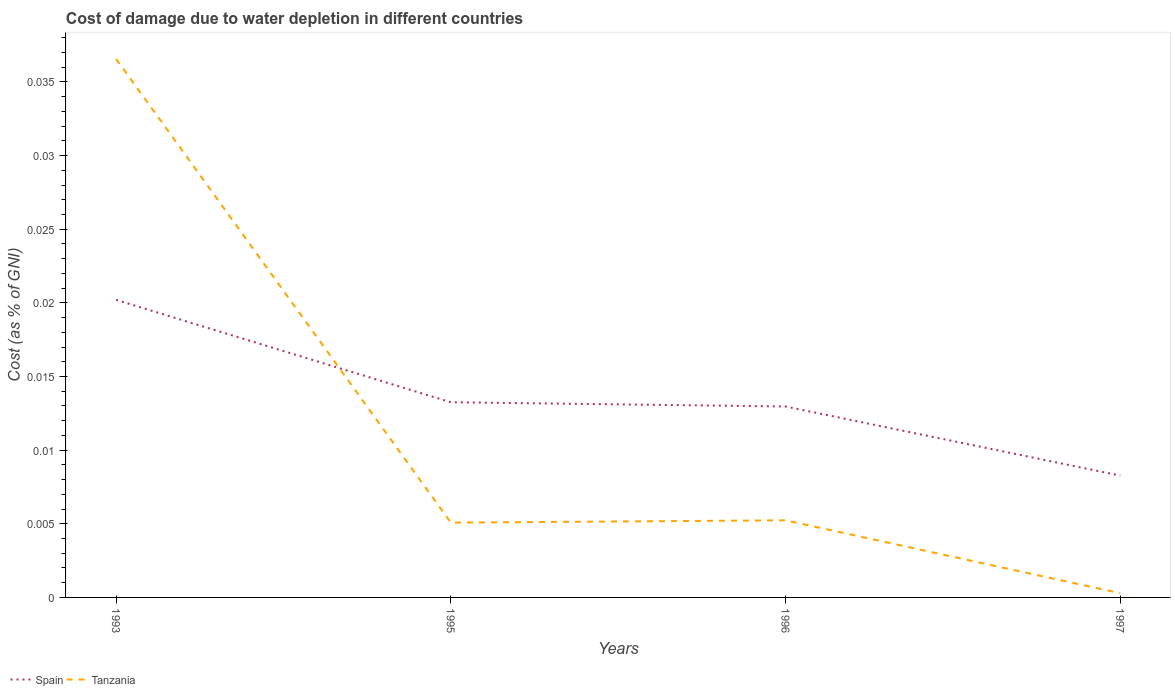Does the line corresponding to Tanzania intersect with the line corresponding to Spain?
Your answer should be very brief. Yes. Is the number of lines equal to the number of legend labels?
Provide a short and direct response. Yes. Across all years, what is the maximum cost of damage caused due to water depletion in Spain?
Your answer should be compact. 0.01. What is the total cost of damage caused due to water depletion in Spain in the graph?
Your response must be concise. 0. What is the difference between the highest and the second highest cost of damage caused due to water depletion in Tanzania?
Provide a short and direct response. 0.04. How many years are there in the graph?
Offer a terse response. 4. What is the difference between two consecutive major ticks on the Y-axis?
Your answer should be compact. 0.01. Does the graph contain any zero values?
Make the answer very short. No. Where does the legend appear in the graph?
Make the answer very short. Bottom left. How many legend labels are there?
Keep it short and to the point. 2. How are the legend labels stacked?
Your answer should be compact. Horizontal. What is the title of the graph?
Your answer should be very brief. Cost of damage due to water depletion in different countries. Does "Maldives" appear as one of the legend labels in the graph?
Your answer should be compact. No. What is the label or title of the X-axis?
Make the answer very short. Years. What is the label or title of the Y-axis?
Make the answer very short. Cost (as % of GNI). What is the Cost (as % of GNI) in Spain in 1993?
Keep it short and to the point. 0.02. What is the Cost (as % of GNI) of Tanzania in 1993?
Offer a very short reply. 0.04. What is the Cost (as % of GNI) in Spain in 1995?
Give a very brief answer. 0.01. What is the Cost (as % of GNI) of Tanzania in 1995?
Offer a very short reply. 0.01. What is the Cost (as % of GNI) in Spain in 1996?
Provide a succinct answer. 0.01. What is the Cost (as % of GNI) of Tanzania in 1996?
Provide a short and direct response. 0.01. What is the Cost (as % of GNI) in Spain in 1997?
Offer a very short reply. 0.01. What is the Cost (as % of GNI) in Tanzania in 1997?
Give a very brief answer. 0. Across all years, what is the maximum Cost (as % of GNI) of Spain?
Provide a short and direct response. 0.02. Across all years, what is the maximum Cost (as % of GNI) of Tanzania?
Your answer should be compact. 0.04. Across all years, what is the minimum Cost (as % of GNI) of Spain?
Your response must be concise. 0.01. Across all years, what is the minimum Cost (as % of GNI) of Tanzania?
Provide a short and direct response. 0. What is the total Cost (as % of GNI) of Spain in the graph?
Keep it short and to the point. 0.05. What is the total Cost (as % of GNI) in Tanzania in the graph?
Your answer should be compact. 0.05. What is the difference between the Cost (as % of GNI) of Spain in 1993 and that in 1995?
Ensure brevity in your answer.  0.01. What is the difference between the Cost (as % of GNI) of Tanzania in 1993 and that in 1995?
Offer a very short reply. 0.03. What is the difference between the Cost (as % of GNI) of Spain in 1993 and that in 1996?
Your answer should be compact. 0.01. What is the difference between the Cost (as % of GNI) in Tanzania in 1993 and that in 1996?
Provide a succinct answer. 0.03. What is the difference between the Cost (as % of GNI) of Spain in 1993 and that in 1997?
Your answer should be very brief. 0.01. What is the difference between the Cost (as % of GNI) of Tanzania in 1993 and that in 1997?
Your answer should be very brief. 0.04. What is the difference between the Cost (as % of GNI) in Spain in 1995 and that in 1996?
Make the answer very short. 0. What is the difference between the Cost (as % of GNI) in Tanzania in 1995 and that in 1996?
Give a very brief answer. -0. What is the difference between the Cost (as % of GNI) of Spain in 1995 and that in 1997?
Ensure brevity in your answer.  0.01. What is the difference between the Cost (as % of GNI) of Tanzania in 1995 and that in 1997?
Provide a succinct answer. 0. What is the difference between the Cost (as % of GNI) of Spain in 1996 and that in 1997?
Ensure brevity in your answer.  0. What is the difference between the Cost (as % of GNI) in Tanzania in 1996 and that in 1997?
Give a very brief answer. 0. What is the difference between the Cost (as % of GNI) of Spain in 1993 and the Cost (as % of GNI) of Tanzania in 1995?
Ensure brevity in your answer.  0.02. What is the difference between the Cost (as % of GNI) of Spain in 1993 and the Cost (as % of GNI) of Tanzania in 1996?
Your answer should be very brief. 0.01. What is the difference between the Cost (as % of GNI) in Spain in 1993 and the Cost (as % of GNI) in Tanzania in 1997?
Offer a terse response. 0.02. What is the difference between the Cost (as % of GNI) in Spain in 1995 and the Cost (as % of GNI) in Tanzania in 1996?
Keep it short and to the point. 0.01. What is the difference between the Cost (as % of GNI) of Spain in 1995 and the Cost (as % of GNI) of Tanzania in 1997?
Give a very brief answer. 0.01. What is the difference between the Cost (as % of GNI) in Spain in 1996 and the Cost (as % of GNI) in Tanzania in 1997?
Your answer should be very brief. 0.01. What is the average Cost (as % of GNI) of Spain per year?
Your answer should be very brief. 0.01. What is the average Cost (as % of GNI) of Tanzania per year?
Make the answer very short. 0.01. In the year 1993, what is the difference between the Cost (as % of GNI) of Spain and Cost (as % of GNI) of Tanzania?
Ensure brevity in your answer.  -0.02. In the year 1995, what is the difference between the Cost (as % of GNI) of Spain and Cost (as % of GNI) of Tanzania?
Your answer should be very brief. 0.01. In the year 1996, what is the difference between the Cost (as % of GNI) of Spain and Cost (as % of GNI) of Tanzania?
Your answer should be compact. 0.01. In the year 1997, what is the difference between the Cost (as % of GNI) of Spain and Cost (as % of GNI) of Tanzania?
Keep it short and to the point. 0.01. What is the ratio of the Cost (as % of GNI) of Spain in 1993 to that in 1995?
Your answer should be very brief. 1.52. What is the ratio of the Cost (as % of GNI) of Tanzania in 1993 to that in 1995?
Provide a succinct answer. 7.2. What is the ratio of the Cost (as % of GNI) in Spain in 1993 to that in 1996?
Give a very brief answer. 1.56. What is the ratio of the Cost (as % of GNI) in Tanzania in 1993 to that in 1996?
Provide a succinct answer. 6.98. What is the ratio of the Cost (as % of GNI) of Spain in 1993 to that in 1997?
Keep it short and to the point. 2.44. What is the ratio of the Cost (as % of GNI) of Tanzania in 1993 to that in 1997?
Give a very brief answer. 127.34. What is the ratio of the Cost (as % of GNI) in Spain in 1995 to that in 1996?
Provide a short and direct response. 1.02. What is the ratio of the Cost (as % of GNI) in Tanzania in 1995 to that in 1996?
Provide a succinct answer. 0.97. What is the ratio of the Cost (as % of GNI) in Spain in 1995 to that in 1997?
Your response must be concise. 1.6. What is the ratio of the Cost (as % of GNI) in Tanzania in 1995 to that in 1997?
Make the answer very short. 17.69. What is the ratio of the Cost (as % of GNI) of Spain in 1996 to that in 1997?
Provide a succinct answer. 1.57. What is the ratio of the Cost (as % of GNI) of Tanzania in 1996 to that in 1997?
Make the answer very short. 18.23. What is the difference between the highest and the second highest Cost (as % of GNI) in Spain?
Give a very brief answer. 0.01. What is the difference between the highest and the second highest Cost (as % of GNI) of Tanzania?
Your answer should be very brief. 0.03. What is the difference between the highest and the lowest Cost (as % of GNI) in Spain?
Your response must be concise. 0.01. What is the difference between the highest and the lowest Cost (as % of GNI) of Tanzania?
Keep it short and to the point. 0.04. 